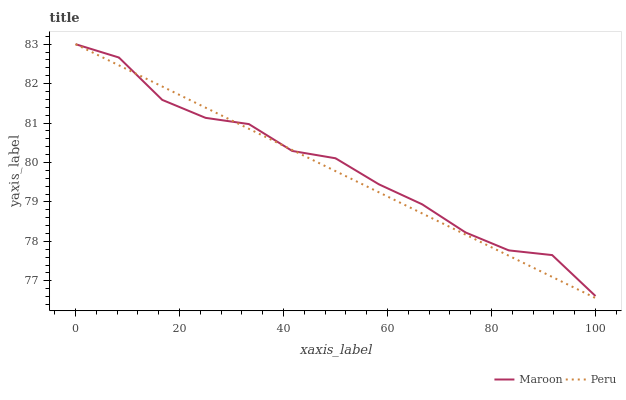Does Peru have the minimum area under the curve?
Answer yes or no. Yes. Does Maroon have the maximum area under the curve?
Answer yes or no. Yes. Does Maroon have the minimum area under the curve?
Answer yes or no. No. Is Peru the smoothest?
Answer yes or no. Yes. Is Maroon the roughest?
Answer yes or no. Yes. Is Maroon the smoothest?
Answer yes or no. No. Does Peru have the lowest value?
Answer yes or no. Yes. Does Maroon have the lowest value?
Answer yes or no. No. Does Maroon have the highest value?
Answer yes or no. Yes. Does Peru intersect Maroon?
Answer yes or no. Yes. Is Peru less than Maroon?
Answer yes or no. No. Is Peru greater than Maroon?
Answer yes or no. No. 